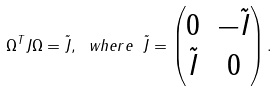<formula> <loc_0><loc_0><loc_500><loc_500>\Omega ^ { T } J \Omega = \tilde { J } , \ w h e r e \ \tilde { J } = \begin{pmatrix} 0 & - \tilde { I } \\ \tilde { I } & 0 \end{pmatrix} .</formula> 